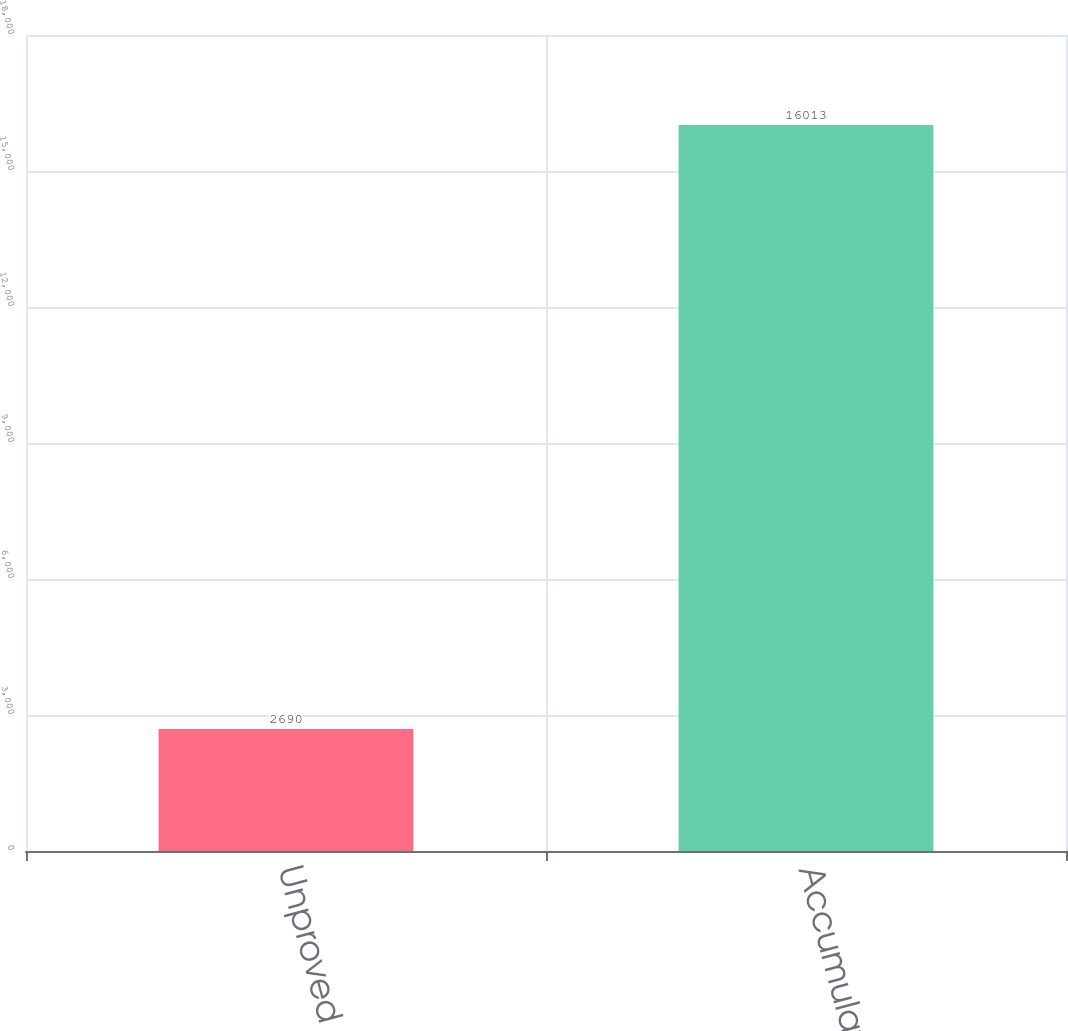Convert chart. <chart><loc_0><loc_0><loc_500><loc_500><bar_chart><fcel>Unproved properties<fcel>Accumulated DD&A<nl><fcel>2690<fcel>16013<nl></chart> 